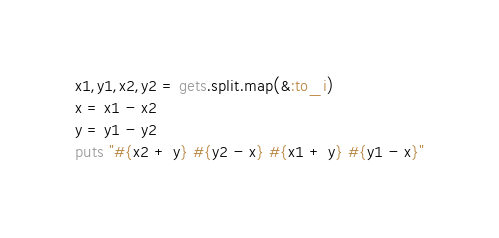Convert code to text. <code><loc_0><loc_0><loc_500><loc_500><_Ruby_>x1,y1,x2,y2 = gets.split.map(&:to_i)
x = x1 - x2
y = y1 - y2
puts "#{x2 + y} #{y2 - x} #{x1 + y} #{y1 - x}"</code> 